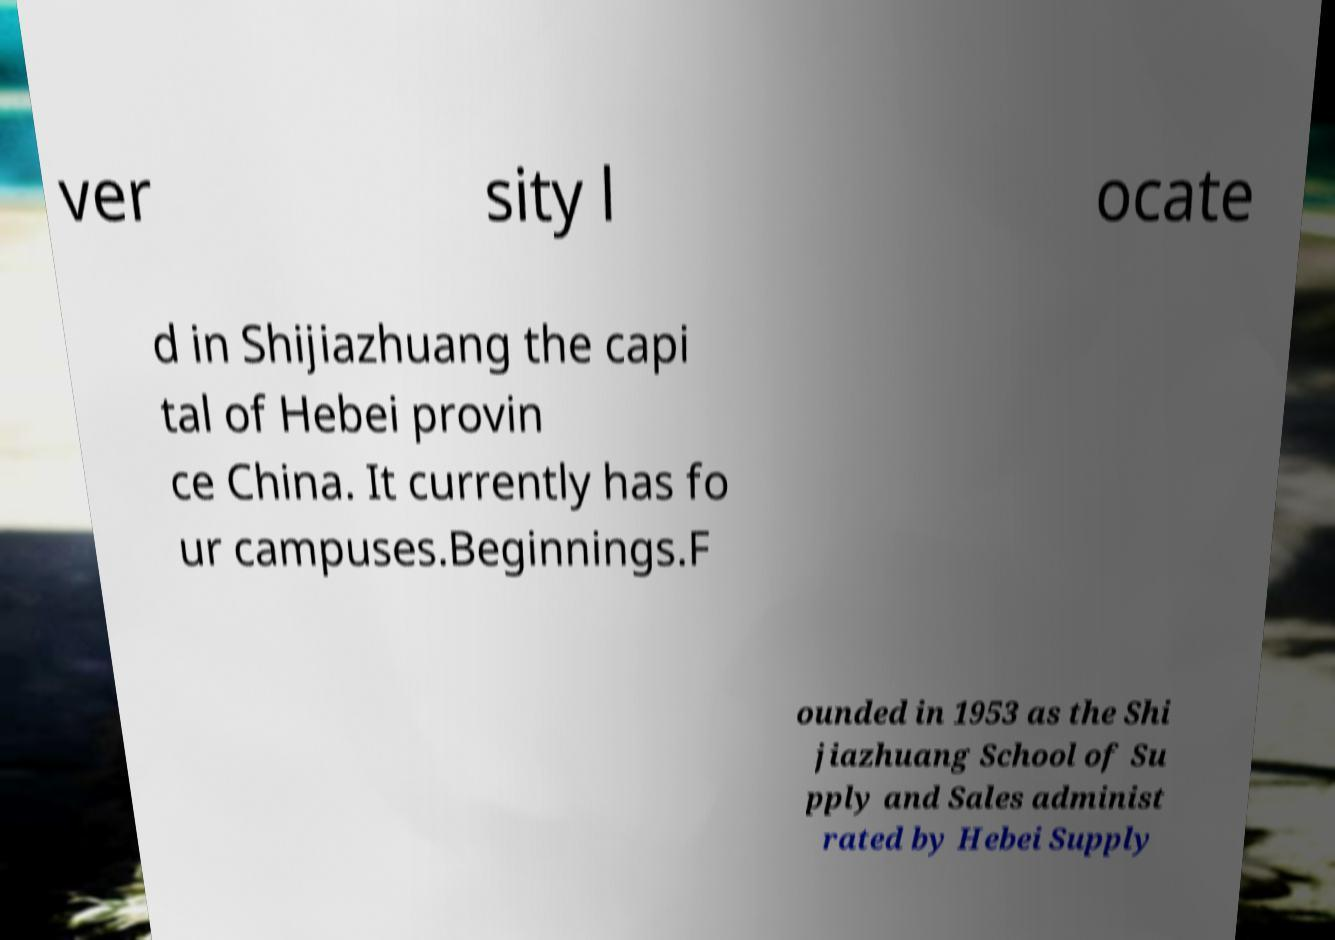Could you assist in decoding the text presented in this image and type it out clearly? ver sity l ocate d in Shijiazhuang the capi tal of Hebei provin ce China. It currently has fo ur campuses.Beginnings.F ounded in 1953 as the Shi jiazhuang School of Su pply and Sales administ rated by Hebei Supply 